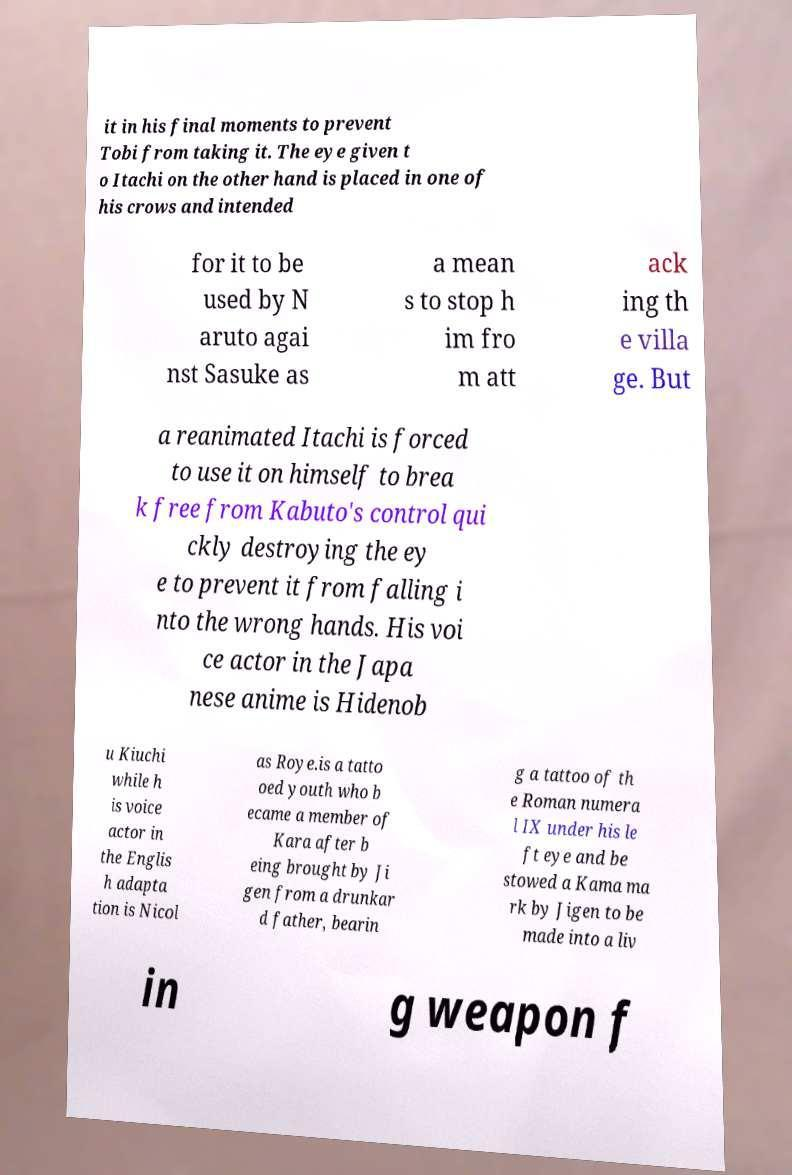I need the written content from this picture converted into text. Can you do that? it in his final moments to prevent Tobi from taking it. The eye given t o Itachi on the other hand is placed in one of his crows and intended for it to be used by N aruto agai nst Sasuke as a mean s to stop h im fro m att ack ing th e villa ge. But a reanimated Itachi is forced to use it on himself to brea k free from Kabuto's control qui ckly destroying the ey e to prevent it from falling i nto the wrong hands. His voi ce actor in the Japa nese anime is Hidenob u Kiuchi while h is voice actor in the Englis h adapta tion is Nicol as Roye.is a tatto oed youth who b ecame a member of Kara after b eing brought by Ji gen from a drunkar d father, bearin g a tattoo of th e Roman numera l IX under his le ft eye and be stowed a Kama ma rk by Jigen to be made into a liv in g weapon f 